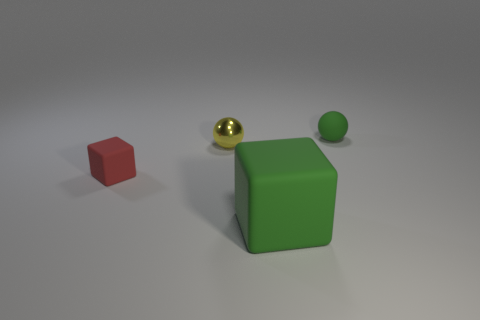Add 3 yellow metallic things. How many objects exist? 7 Subtract all red cubes. How many cubes are left? 1 Subtract all tiny red cubes. Subtract all large rubber cubes. How many objects are left? 2 Add 1 tiny green things. How many tiny green things are left? 2 Add 2 big green rubber things. How many big green rubber things exist? 3 Subtract 0 gray balls. How many objects are left? 4 Subtract 1 cubes. How many cubes are left? 1 Subtract all yellow balls. Subtract all green cylinders. How many balls are left? 1 Subtract all gray spheres. How many red blocks are left? 1 